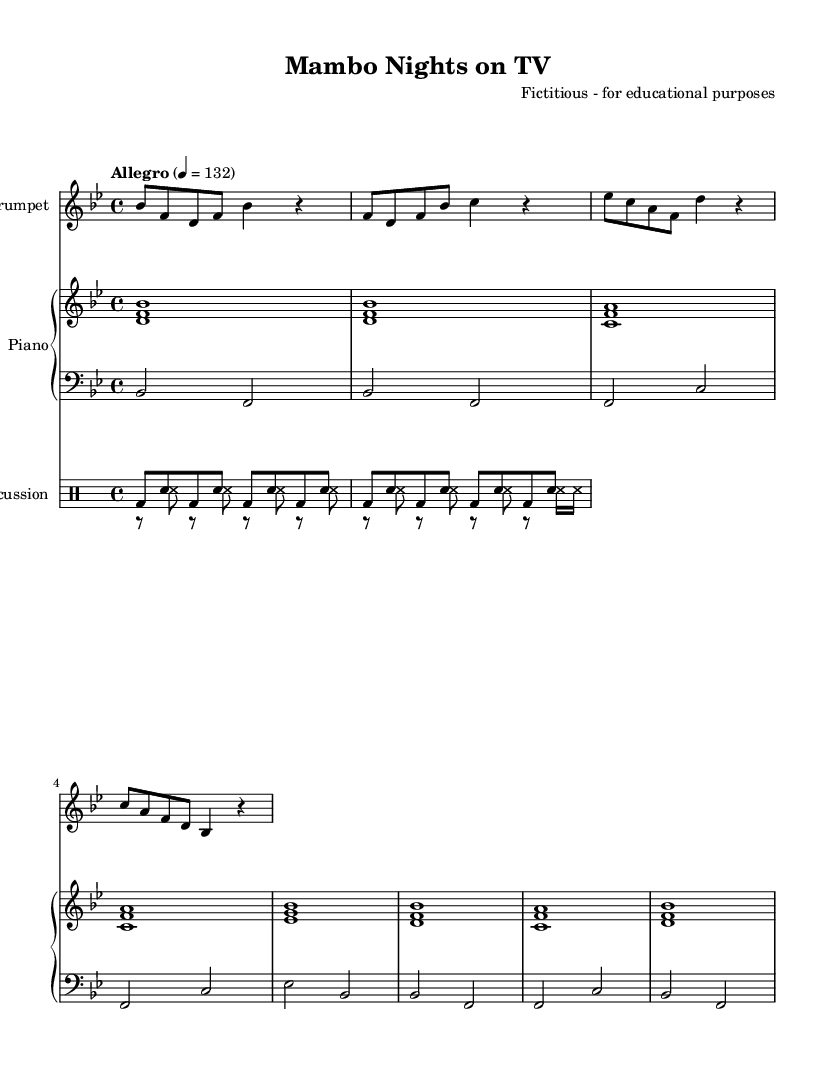What is the key signature of this music? The key signature appears at the beginning of the staff. In this case, it shows two flats, indicating the key of B-flat major.
Answer: B-flat major What is the time signature of this music? The time signature is located at the beginning and is notated as 4 over 4, indicating a regular four beats per measure.
Answer: 4/4 What is the tempo marking of this music? The tempo marking specifies "Allegro" and indicates a speed of 132 beats per minute, which is shown in a separate line near the beginning.
Answer: Allegro, 132 What instruments are present in this score? The score includes a trumpet, piano (with bass), and percussion (congas and timbales), which can be identified by their respective instrument names in the score.
Answer: Trumpet, Piano, Congas, Timbales Which measure features a rest in the trumpet part? By examining the trumpet part, measure 2 shows a quarter rest, indicating no sound should be played during that beat.
Answer: Measure 2 How many beats are indicated in the bass part for measure 1? In the bass part, measure 1 has a whole note that represents two beats, filled by the notes played.
Answer: Two beats What rhythmic elements are characteristic of Latin music as shown in the drum parts? The drum parts exhibit patterns typical of Latin music, characterized by the use of syncopation and distinct patterns like the conga and timbales, seen in the drumming notation throughout the piece.
Answer: Syncopated rhythms 